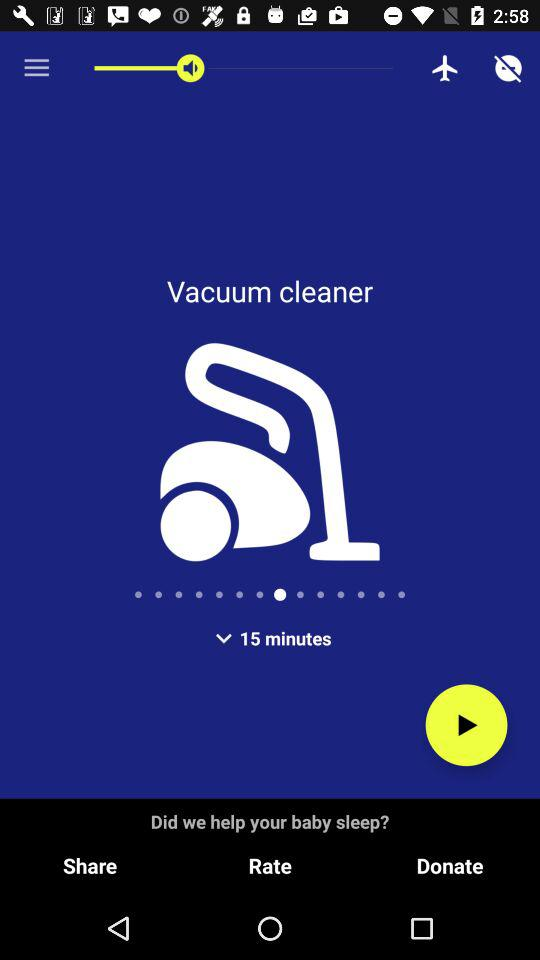What is the name of the application? The name of the application is "Vaccum Cleaner Sounds". 